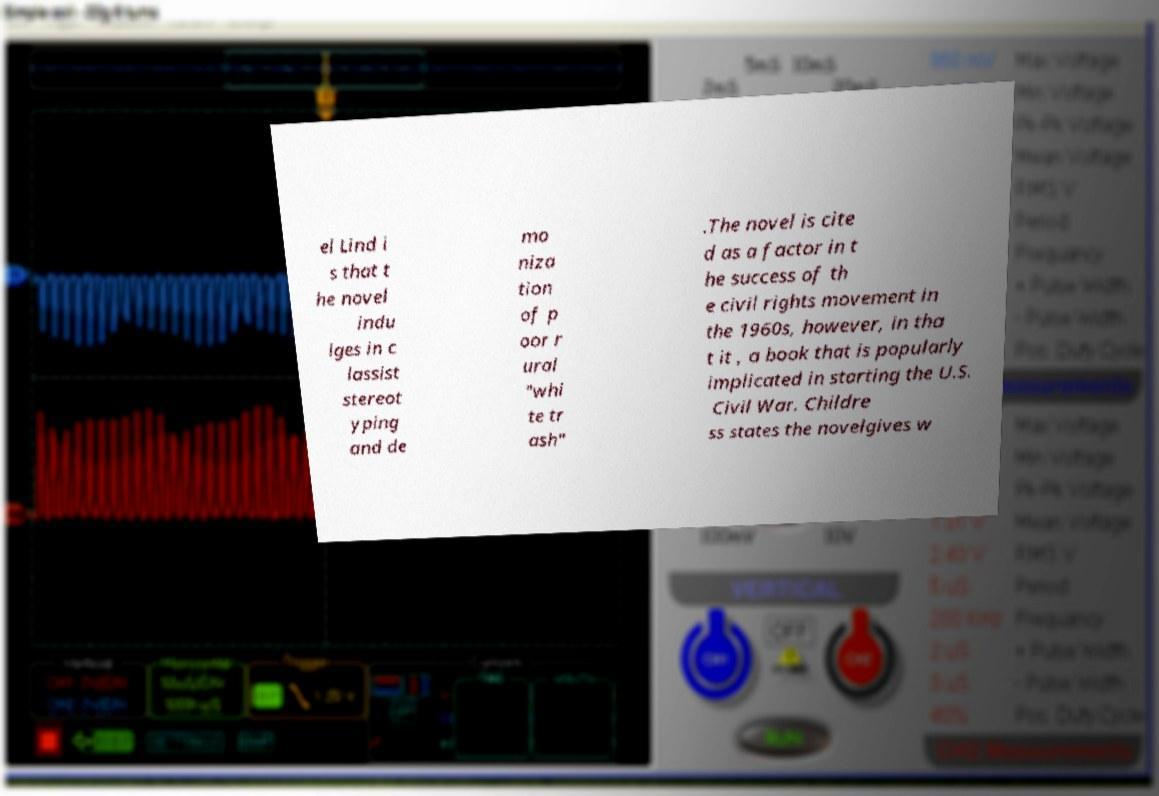Could you assist in decoding the text presented in this image and type it out clearly? el Lind i s that t he novel indu lges in c lassist stereot yping and de mo niza tion of p oor r ural "whi te tr ash" .The novel is cite d as a factor in t he success of th e civil rights movement in the 1960s, however, in tha t it , a book that is popularly implicated in starting the U.S. Civil War. Childre ss states the novelgives w 